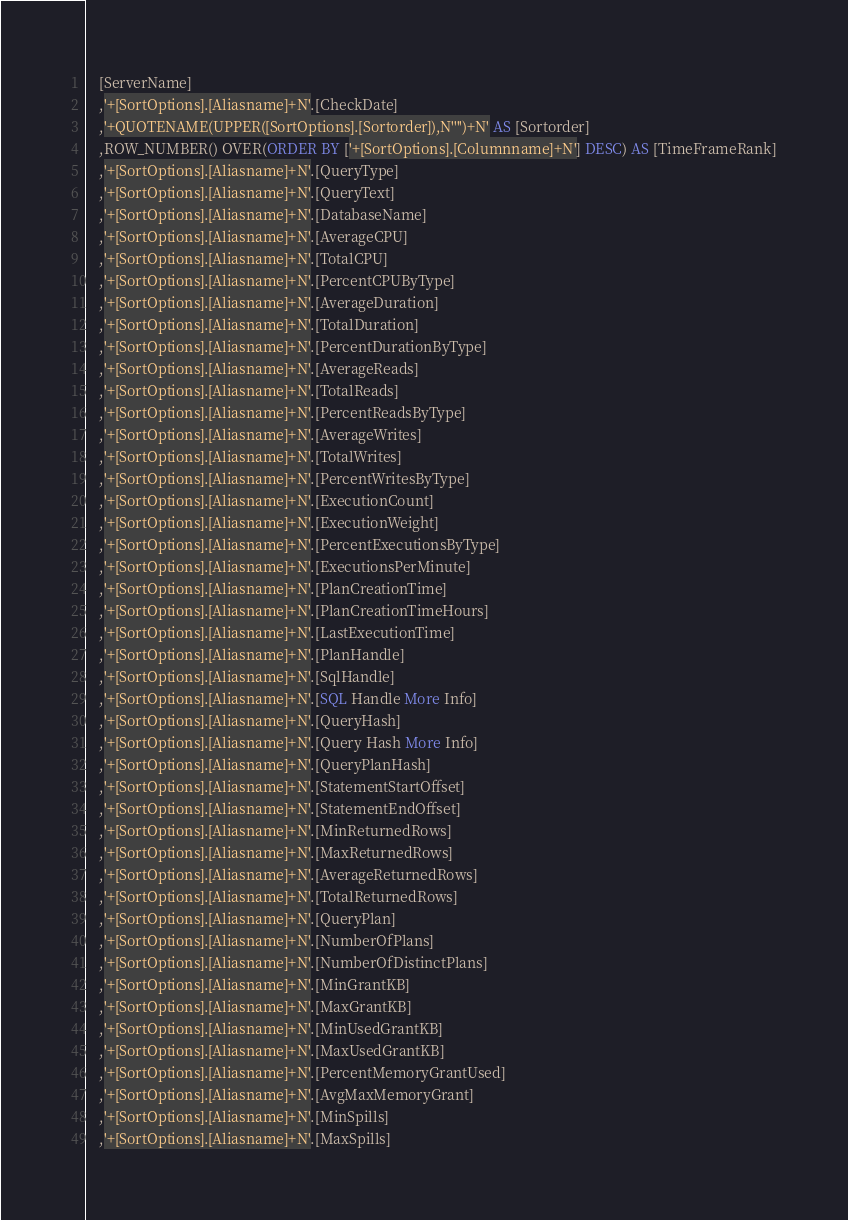<code> <loc_0><loc_0><loc_500><loc_500><_SQL_>	[ServerName]
    ,'+[SortOptions].[Aliasname]+N'.[CheckDate]
	,'+QUOTENAME(UPPER([SortOptions].[Sortorder]),N'''')+N' AS [Sortorder]
	,ROW_NUMBER() OVER(ORDER BY ['+[SortOptions].[Columnname]+N'] DESC) AS [TimeFrameRank]
	,'+[SortOptions].[Aliasname]+N'.[QueryType]
	,'+[SortOptions].[Aliasname]+N'.[QueryText]
	,'+[SortOptions].[Aliasname]+N'.[DatabaseName]
	,'+[SortOptions].[Aliasname]+N'.[AverageCPU]
	,'+[SortOptions].[Aliasname]+N'.[TotalCPU]
	,'+[SortOptions].[Aliasname]+N'.[PercentCPUByType]
	,'+[SortOptions].[Aliasname]+N'.[AverageDuration]
	,'+[SortOptions].[Aliasname]+N'.[TotalDuration]
	,'+[SortOptions].[Aliasname]+N'.[PercentDurationByType]
	,'+[SortOptions].[Aliasname]+N'.[AverageReads]
	,'+[SortOptions].[Aliasname]+N'.[TotalReads]
	,'+[SortOptions].[Aliasname]+N'.[PercentReadsByType]
	,'+[SortOptions].[Aliasname]+N'.[AverageWrites]
	,'+[SortOptions].[Aliasname]+N'.[TotalWrites]
	,'+[SortOptions].[Aliasname]+N'.[PercentWritesByType]
	,'+[SortOptions].[Aliasname]+N'.[ExecutionCount]
	,'+[SortOptions].[Aliasname]+N'.[ExecutionWeight]
	,'+[SortOptions].[Aliasname]+N'.[PercentExecutionsByType]
	,'+[SortOptions].[Aliasname]+N'.[ExecutionsPerMinute]
	,'+[SortOptions].[Aliasname]+N'.[PlanCreationTime]
	,'+[SortOptions].[Aliasname]+N'.[PlanCreationTimeHours]
	,'+[SortOptions].[Aliasname]+N'.[LastExecutionTime]
	,'+[SortOptions].[Aliasname]+N'.[PlanHandle]
	,'+[SortOptions].[Aliasname]+N'.[SqlHandle]
	,'+[SortOptions].[Aliasname]+N'.[SQL Handle More Info]
	,'+[SortOptions].[Aliasname]+N'.[QueryHash]
	,'+[SortOptions].[Aliasname]+N'.[Query Hash More Info]
	,'+[SortOptions].[Aliasname]+N'.[QueryPlanHash]
	,'+[SortOptions].[Aliasname]+N'.[StatementStartOffset]
	,'+[SortOptions].[Aliasname]+N'.[StatementEndOffset]
	,'+[SortOptions].[Aliasname]+N'.[MinReturnedRows]
	,'+[SortOptions].[Aliasname]+N'.[MaxReturnedRows]
	,'+[SortOptions].[Aliasname]+N'.[AverageReturnedRows]
	,'+[SortOptions].[Aliasname]+N'.[TotalReturnedRows]
	,'+[SortOptions].[Aliasname]+N'.[QueryPlan]
	,'+[SortOptions].[Aliasname]+N'.[NumberOfPlans]
	,'+[SortOptions].[Aliasname]+N'.[NumberOfDistinctPlans]
	,'+[SortOptions].[Aliasname]+N'.[MinGrantKB]
	,'+[SortOptions].[Aliasname]+N'.[MaxGrantKB]
	,'+[SortOptions].[Aliasname]+N'.[MinUsedGrantKB]
	,'+[SortOptions].[Aliasname]+N'.[MaxUsedGrantKB]
	,'+[SortOptions].[Aliasname]+N'.[PercentMemoryGrantUsed]
	,'+[SortOptions].[Aliasname]+N'.[AvgMaxMemoryGrant]
	,'+[SortOptions].[Aliasname]+N'.[MinSpills]
	,'+[SortOptions].[Aliasname]+N'.[MaxSpills]</code> 